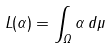<formula> <loc_0><loc_0><loc_500><loc_500>L ( \alpha ) = \int _ { \Omega } \alpha \, d \mu</formula> 